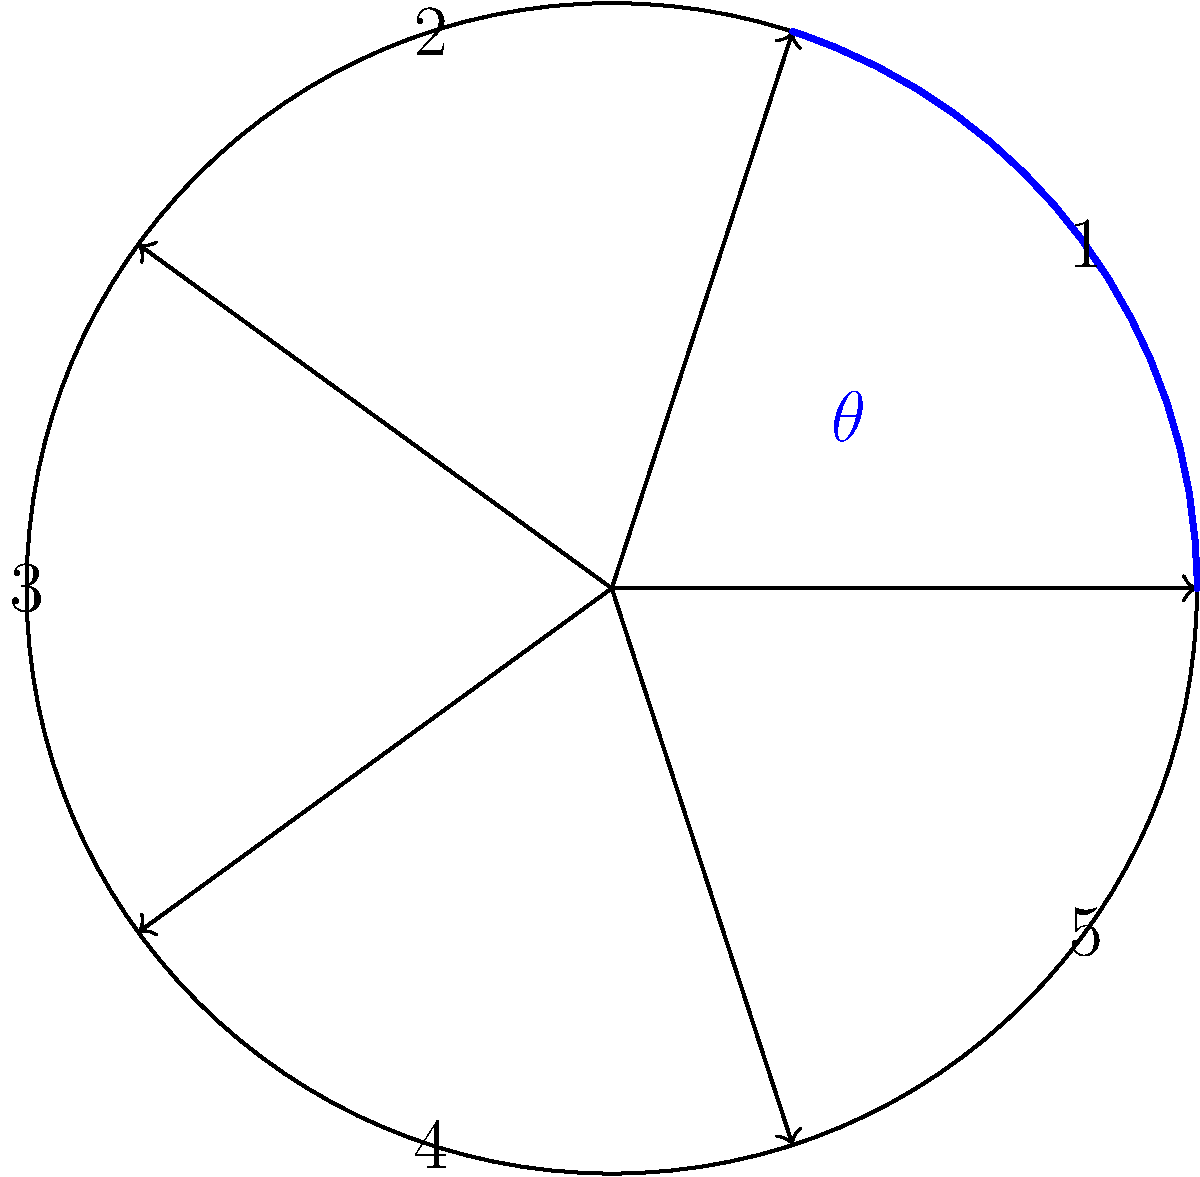In composing a symphony inspired by an ancient epic cycle with five distinct movements, you decide to represent each movement as a section of a circle. If the central angle for each section is equal, what is the measure of the central angle $\theta$ (in degrees) for each movement? To solve this problem, let's follow these steps:

1) First, recall that a full circle contains 360°.

2) The symphony has five distinct movements, each represented by an equal section of the circle.

3) To find the central angle for each section, we need to divide the total degrees in a circle by the number of sections:

   $\theta = \frac{\text{Total degrees in a circle}}{\text{Number of sections}}$

4) Substituting the values:

   $\theta = \frac{360°}{5}$

5) Perform the division:

   $\theta = 72°$

Therefore, each section of the circle, representing a movement in the symphony, has a central angle of 72°.
Answer: 72° 